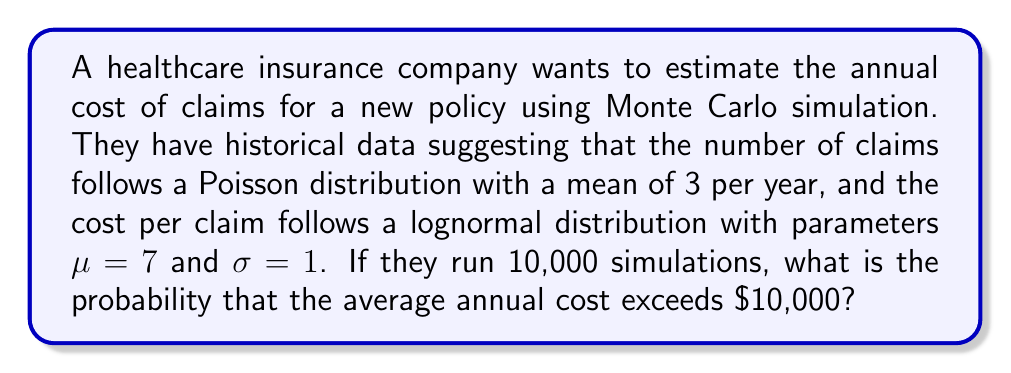Give your solution to this math problem. Let's approach this step-by-step:

1) First, we need to understand what each simulation represents:
   - Generate a random number of claims from Poisson(3)
   - For each claim, generate a random cost from Lognormal(7, 1)
   - Sum these costs to get the total annual cost

2) The Central Limit Theorem tells us that the distribution of the average of these 10,000 simulations will be approximately normal.

3) To solve this, we need to:
   a) Calculate the expected value of the annual cost
   b) Calculate the standard deviation of the annual cost
   c) Use these to find the z-score for $10,000
   d) Use the z-score to find the probability

4) Expected value calculation:
   E[Annual Cost] = E[Number of Claims] * E[Cost per Claim]
   E[Number of Claims] = 3 (given Poisson mean)
   E[Cost per Claim] = e^(μ + σ^2/2) = e^(7 + 1^2/2) ≈ 1808.04
   E[Annual Cost] = 3 * 1808.04 ≈ 5424.12

5) Variance calculation:
   Var[Annual Cost] = E[Number of Claims] * Var[Cost per Claim]
   Var[Cost per Claim] = (e^σ^2 - 1) * e^(2μ + σ^2) ≈ 6,235,290
   Var[Annual Cost] = 3 * 6,235,290 ≈ 18,705,870

6) Standard deviation of annual cost:
   SD[Annual Cost] = √18,705,870 ≈ 4324.57

7) Standard error of the mean (SEM) for 10,000 simulations:
   SEM = 4324.57 / √10000 ≈ 43.25

8) Z-score for $10,000:
   z = (10000 - 5424.12) / 43.25 ≈ 105.80

9) The probability of exceeding $10,000 is the area to the right of this z-score on a standard normal distribution:
   P(Z > 105.80) ≈ 0
Answer: $\approx 0$ 